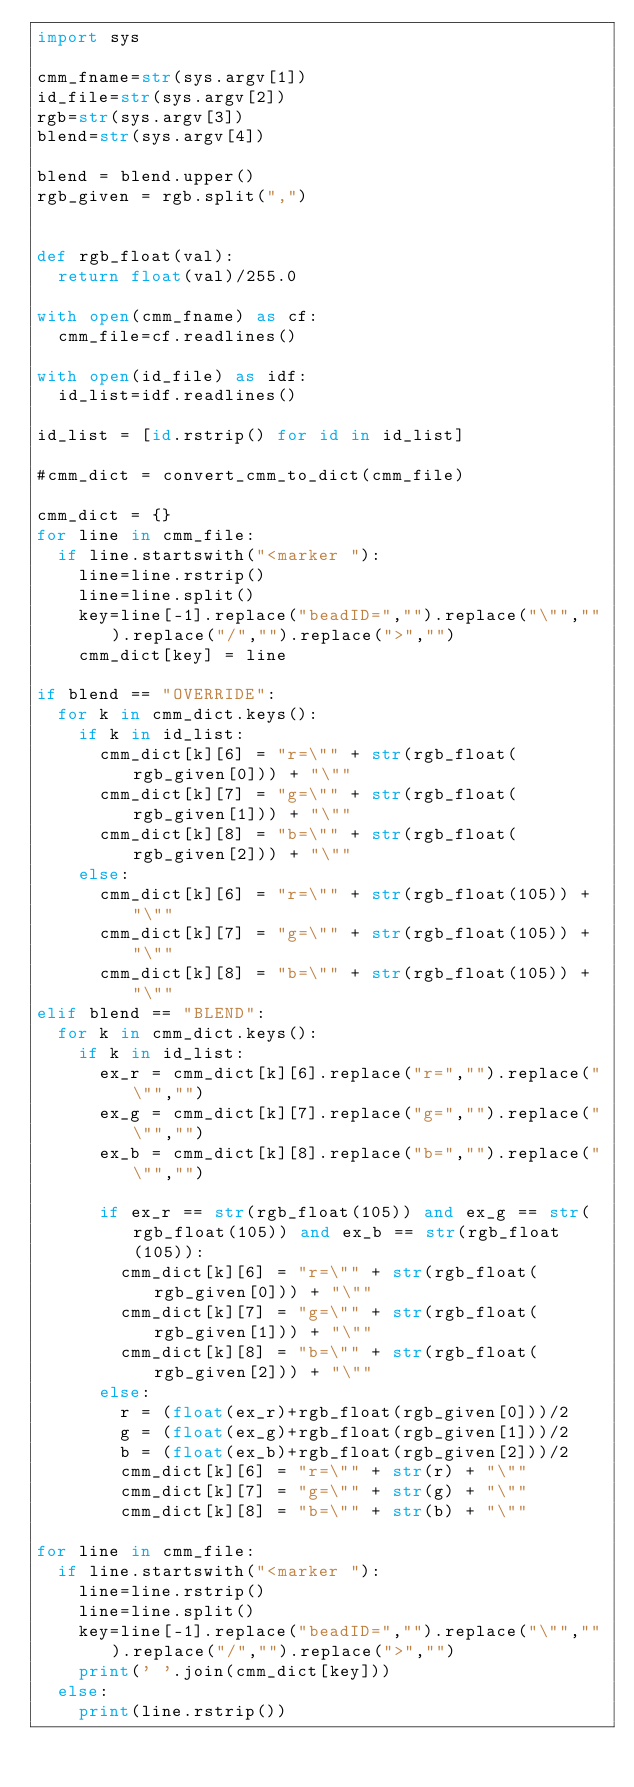<code> <loc_0><loc_0><loc_500><loc_500><_Python_>import sys

cmm_fname=str(sys.argv[1])
id_file=str(sys.argv[2])
rgb=str(sys.argv[3])
blend=str(sys.argv[4])

blend = blend.upper()
rgb_given = rgb.split(",")


def rgb_float(val):
  return float(val)/255.0

with open(cmm_fname) as cf:
  cmm_file=cf.readlines()

with open(id_file) as idf:
  id_list=idf.readlines()

id_list = [id.rstrip() for id in id_list]

#cmm_dict = convert_cmm_to_dict(cmm_file)

cmm_dict = {}
for line in cmm_file:
  if line.startswith("<marker "):
    line=line.rstrip()
    line=line.split()
    key=line[-1].replace("beadID=","").replace("\"","").replace("/","").replace(">","")
    cmm_dict[key] = line

if blend == "OVERRIDE": 
  for k in cmm_dict.keys():
    if k in id_list:
      cmm_dict[k][6] = "r=\"" + str(rgb_float(rgb_given[0])) + "\""
      cmm_dict[k][7] = "g=\"" + str(rgb_float(rgb_given[1])) + "\""
      cmm_dict[k][8] = "b=\"" + str(rgb_float(rgb_given[2])) + "\""
    else:
      cmm_dict[k][6] = "r=\"" + str(rgb_float(105)) + "\""
      cmm_dict[k][7] = "g=\"" + str(rgb_float(105)) + "\""
      cmm_dict[k][8] = "b=\"" + str(rgb_float(105)) + "\""
elif blend == "BLEND":
  for k in cmm_dict.keys():
    if k in id_list:
      ex_r = cmm_dict[k][6].replace("r=","").replace("\"","")
      ex_g = cmm_dict[k][7].replace("g=","").replace("\"","")
      ex_b = cmm_dict[k][8].replace("b=","").replace("\"","")
     
      if ex_r == str(rgb_float(105)) and ex_g == str(rgb_float(105)) and ex_b == str(rgb_float(105)):
        cmm_dict[k][6] = "r=\"" + str(rgb_float(rgb_given[0])) + "\""
        cmm_dict[k][7] = "g=\"" + str(rgb_float(rgb_given[1])) + "\""
        cmm_dict[k][8] = "b=\"" + str(rgb_float(rgb_given[2])) + "\""
      else:
        r = (float(ex_r)+rgb_float(rgb_given[0]))/2
        g = (float(ex_g)+rgb_float(rgb_given[1]))/2
        b = (float(ex_b)+rgb_float(rgb_given[2]))/2
        cmm_dict[k][6] = "r=\"" + str(r) + "\""
        cmm_dict[k][7] = "g=\"" + str(g) + "\""
        cmm_dict[k][8] = "b=\"" + str(b) + "\""

for line in cmm_file:
  if line.startswith("<marker "):
    line=line.rstrip()
    line=line.split()
    key=line[-1].replace("beadID=","").replace("\"","").replace("/","").replace(">","")
    print(' '.join(cmm_dict[key]))
  else:
    print(line.rstrip())
</code> 